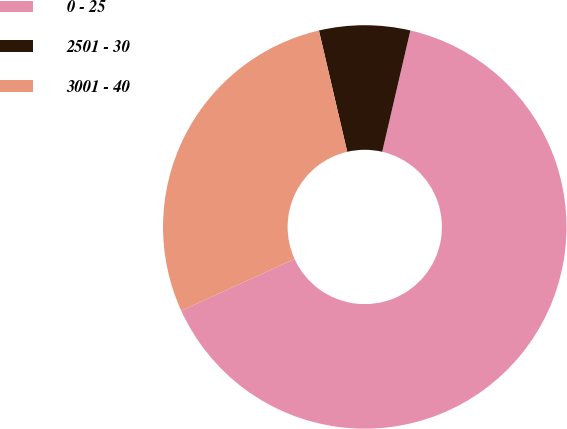Convert chart. <chart><loc_0><loc_0><loc_500><loc_500><pie_chart><fcel>0 - 25<fcel>2501 - 30<fcel>3001 - 40<nl><fcel>64.56%<fcel>7.28%<fcel>28.16%<nl></chart> 